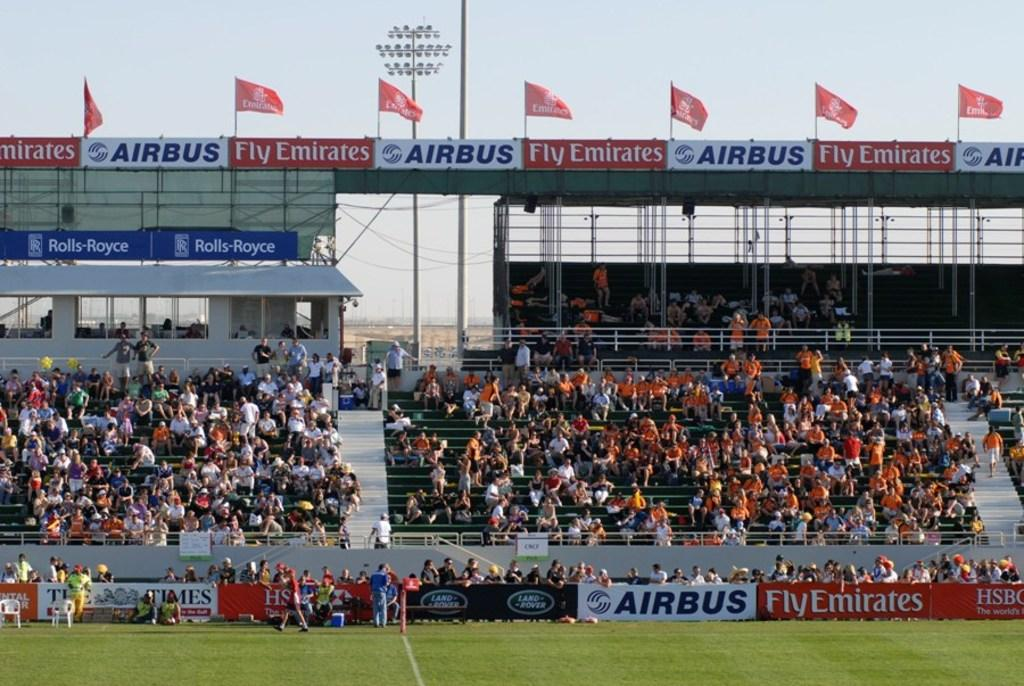<image>
Relay a brief, clear account of the picture shown. Emirates and Airbus are the main sponsors of this stadium. 